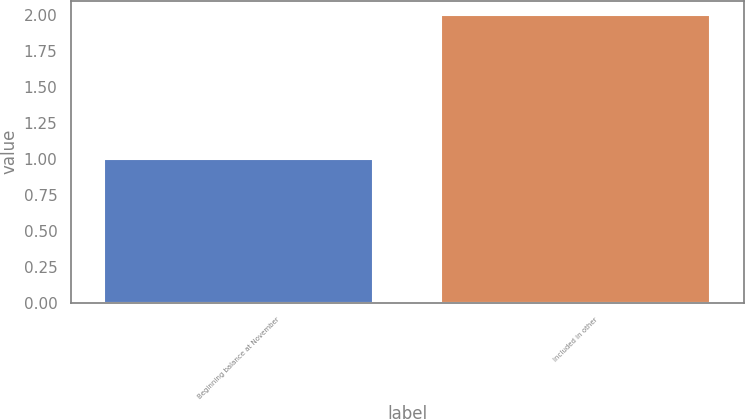Convert chart. <chart><loc_0><loc_0><loc_500><loc_500><bar_chart><fcel>Beginning balance at November<fcel>Included in other<nl><fcel>1<fcel>2<nl></chart> 